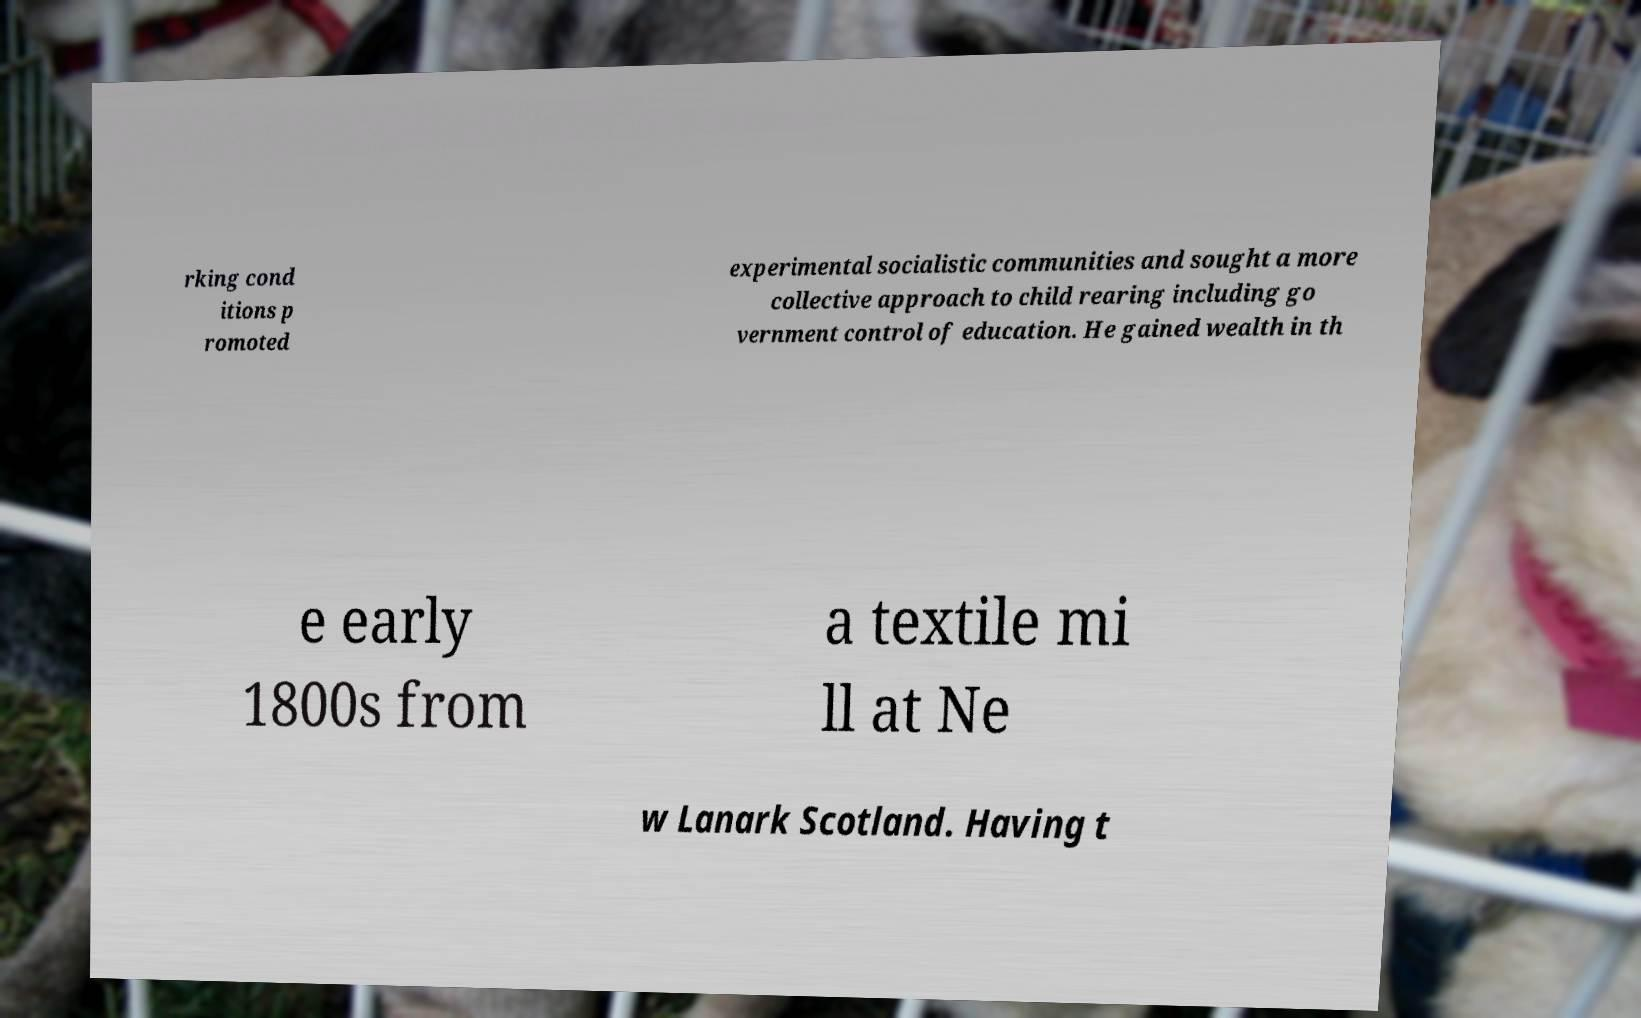Please read and relay the text visible in this image. What does it say? rking cond itions p romoted experimental socialistic communities and sought a more collective approach to child rearing including go vernment control of education. He gained wealth in th e early 1800s from a textile mi ll at Ne w Lanark Scotland. Having t 